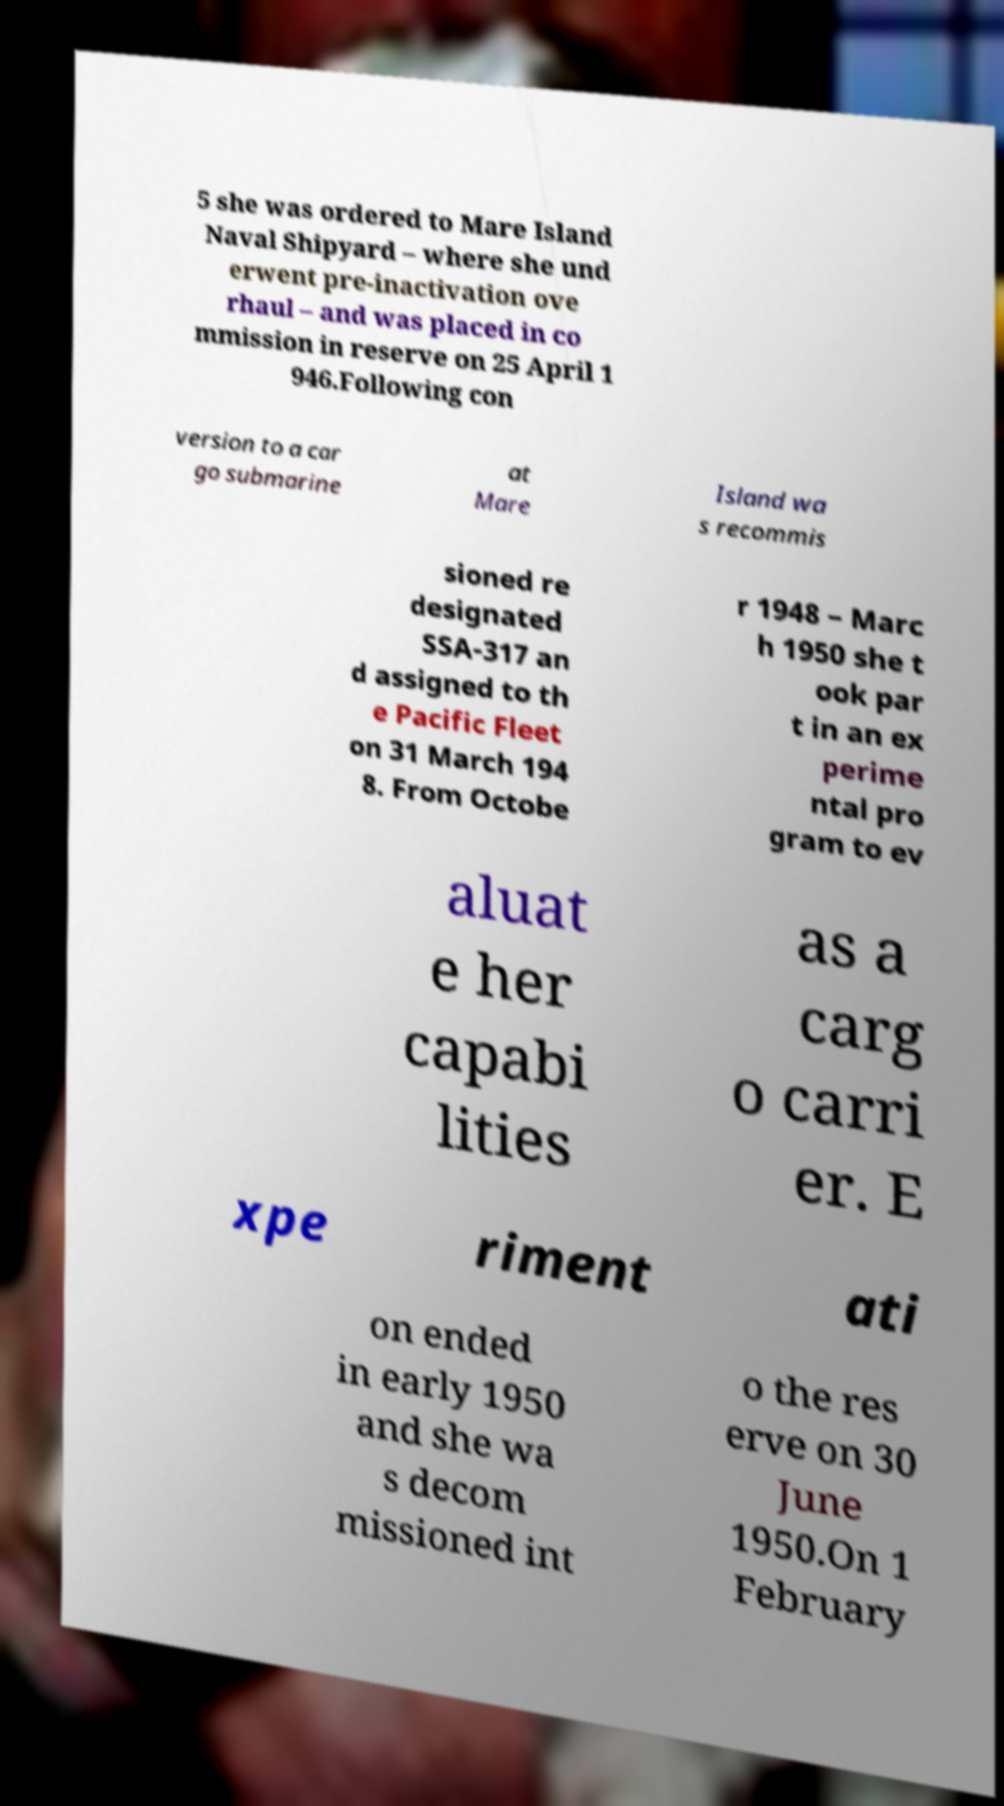Please identify and transcribe the text found in this image. 5 she was ordered to Mare Island Naval Shipyard – where she und erwent pre-inactivation ove rhaul – and was placed in co mmission in reserve on 25 April 1 946.Following con version to a car go submarine at Mare Island wa s recommis sioned re designated SSA-317 an d assigned to th e Pacific Fleet on 31 March 194 8. From Octobe r 1948 – Marc h 1950 she t ook par t in an ex perime ntal pro gram to ev aluat e her capabi lities as a carg o carri er. E xpe riment ati on ended in early 1950 and she wa s decom missioned int o the res erve on 30 June 1950.On 1 February 